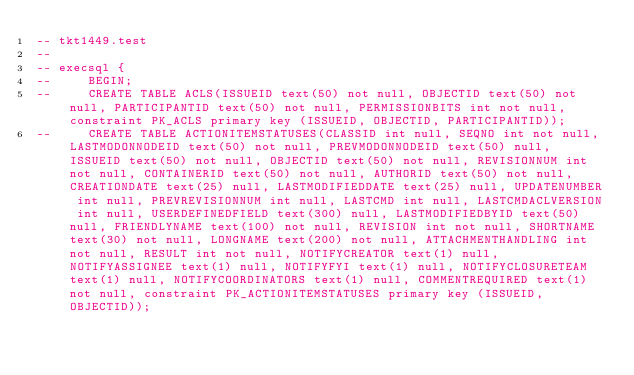Convert code to text. <code><loc_0><loc_0><loc_500><loc_500><_SQL_>-- tkt1449.test
-- 
-- execsql {
--     BEGIN;
--     CREATE TABLE ACLS(ISSUEID text(50) not null, OBJECTID text(50) not null, PARTICIPANTID text(50) not null, PERMISSIONBITS int not null, constraint PK_ACLS primary key (ISSUEID, OBJECTID, PARTICIPANTID));
--     CREATE TABLE ACTIONITEMSTATUSES(CLASSID int null, SEQNO int not null, LASTMODONNODEID text(50) not null, PREVMODONNODEID text(50) null, ISSUEID text(50) not null, OBJECTID text(50) not null, REVISIONNUM int not null, CONTAINERID text(50) not null, AUTHORID text(50) not null, CREATIONDATE text(25) null, LASTMODIFIEDDATE text(25) null, UPDATENUMBER int null, PREVREVISIONNUM int null, LASTCMD int null, LASTCMDACLVERSION int null, USERDEFINEDFIELD text(300) null, LASTMODIFIEDBYID text(50) null, FRIENDLYNAME text(100) not null, REVISION int not null, SHORTNAME text(30) not null, LONGNAME text(200) not null, ATTACHMENTHANDLING int not null, RESULT int not null, NOTIFYCREATOR text(1) null, NOTIFYASSIGNEE text(1) null, NOTIFYFYI text(1) null, NOTIFYCLOSURETEAM text(1) null, NOTIFYCOORDINATORS text(1) null, COMMENTREQUIRED text(1) not null, constraint PK_ACTIONITEMSTATUSES primary key (ISSUEID, OBJECTID));</code> 